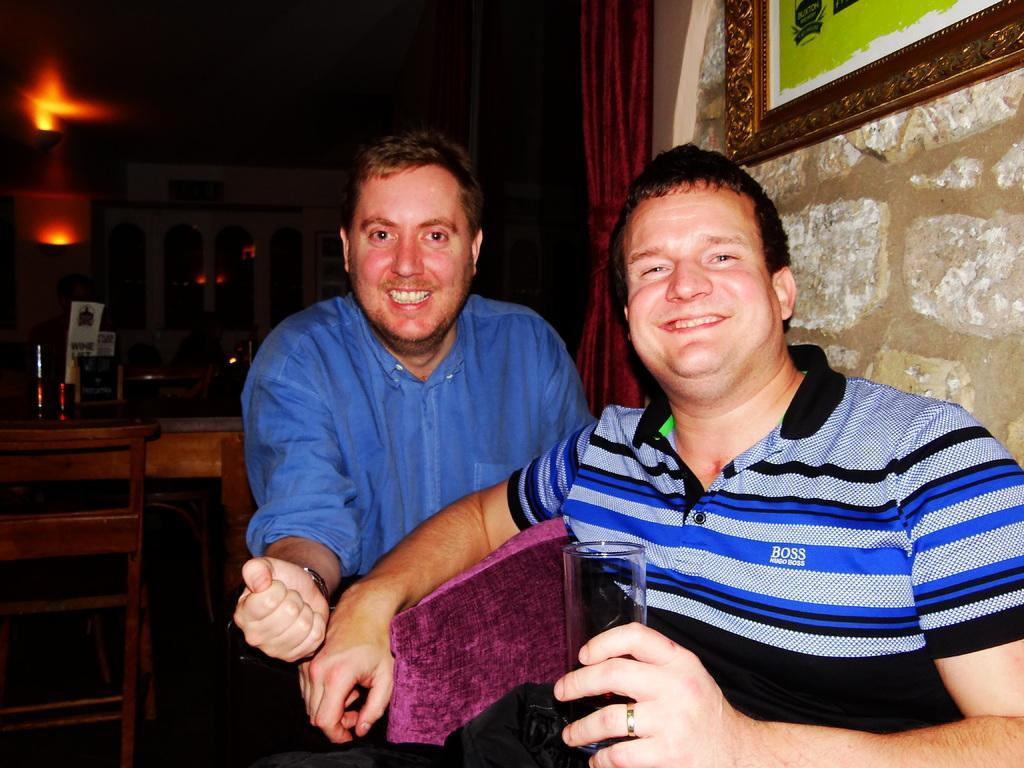Can you describe this image briefly? These two persons are sitting on a chair and holding a glass and smiling. We can able to see chairs and tables. On top there are lights. A picture on wall. 